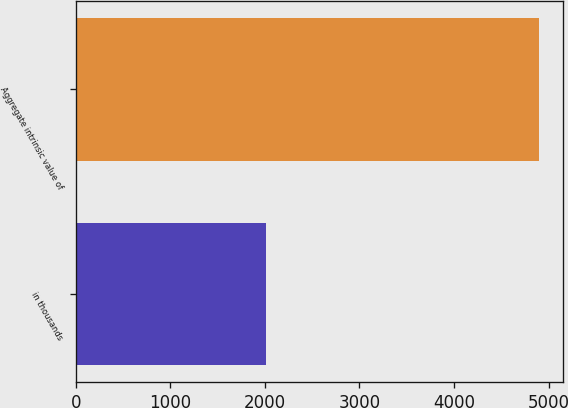Convert chart to OTSL. <chart><loc_0><loc_0><loc_500><loc_500><bar_chart><fcel>in thousands<fcel>Aggregate intrinsic value of<nl><fcel>2009<fcel>4903<nl></chart> 